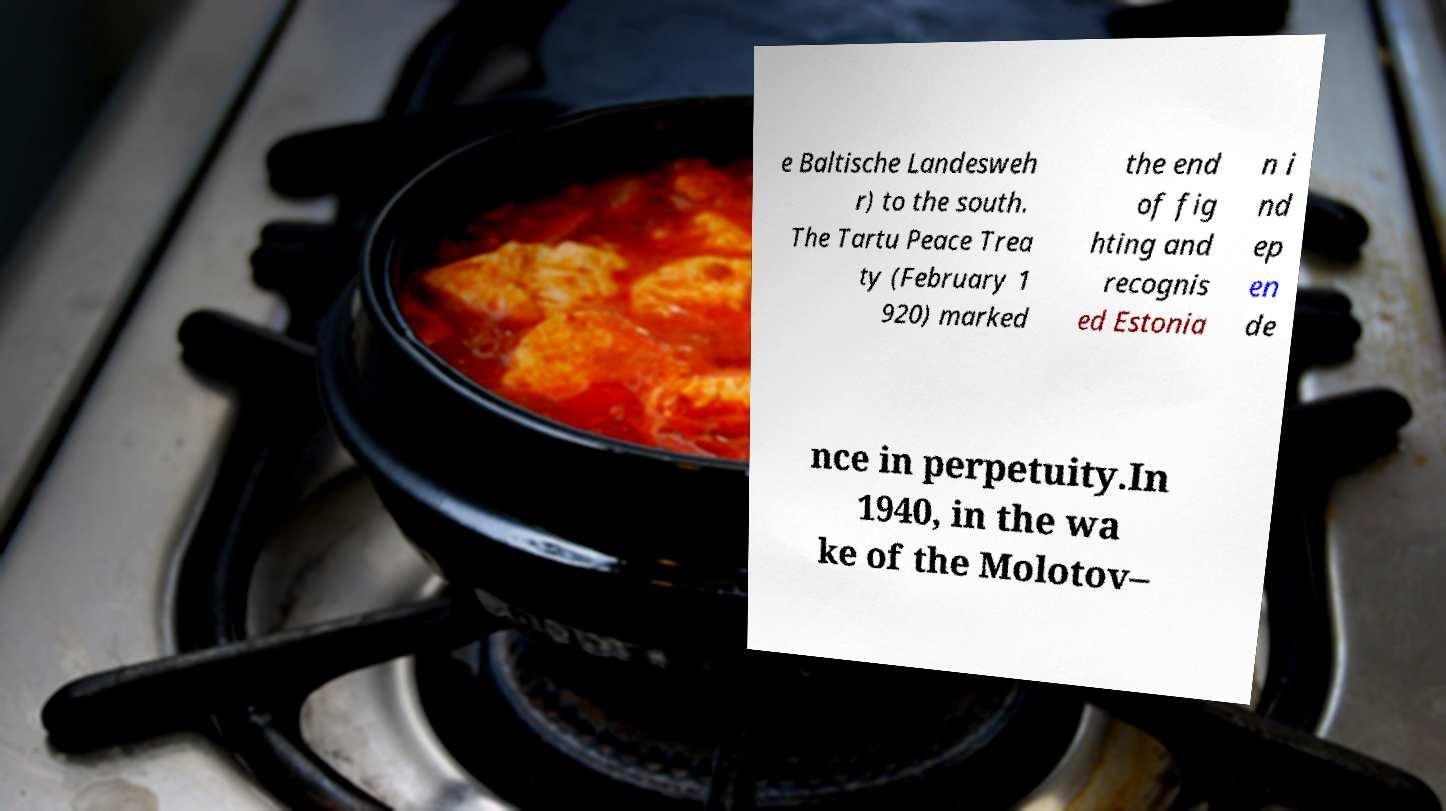Can you read and provide the text displayed in the image?This photo seems to have some interesting text. Can you extract and type it out for me? e Baltische Landesweh r) to the south. The Tartu Peace Trea ty (February 1 920) marked the end of fig hting and recognis ed Estonia n i nd ep en de nce in perpetuity.In 1940, in the wa ke of the Molotov– 